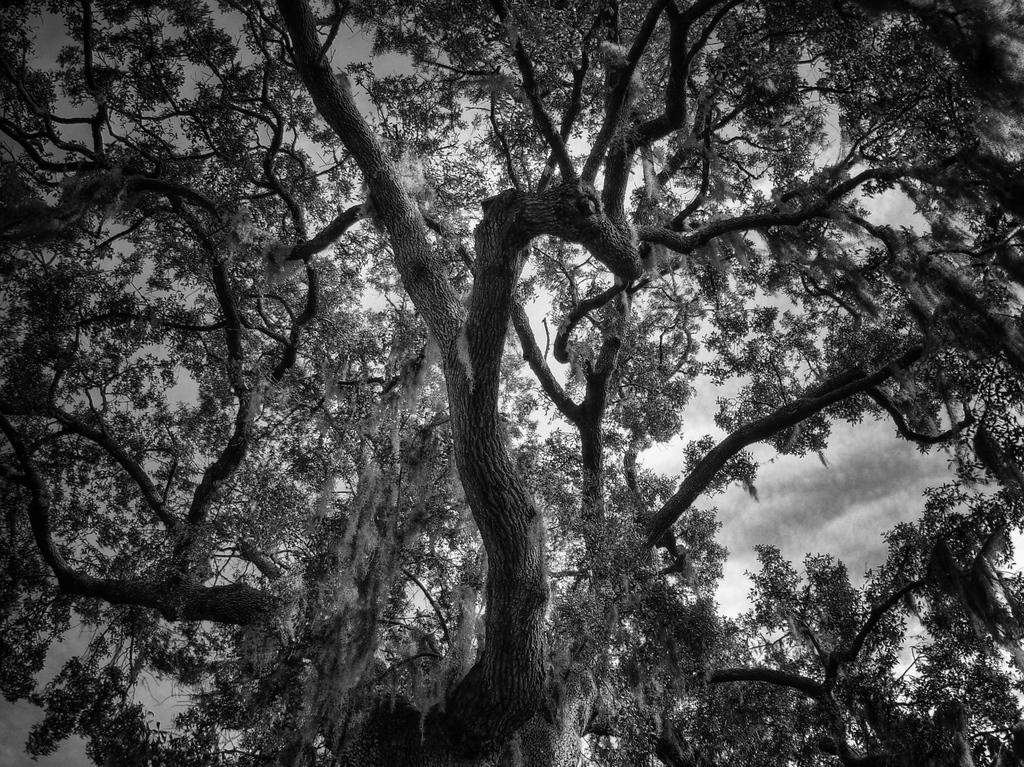What is the main subject in the foreground of the image? There is a tree with many branches in the foreground of the image. What can be seen in the background of the image? The sky is visible in the image. What is the condition of the sky in the image? There are clouds in the sky. Where is the body of the horse located in the image? There is no horse present in the image, so it is not possible to determine the location of its body. 